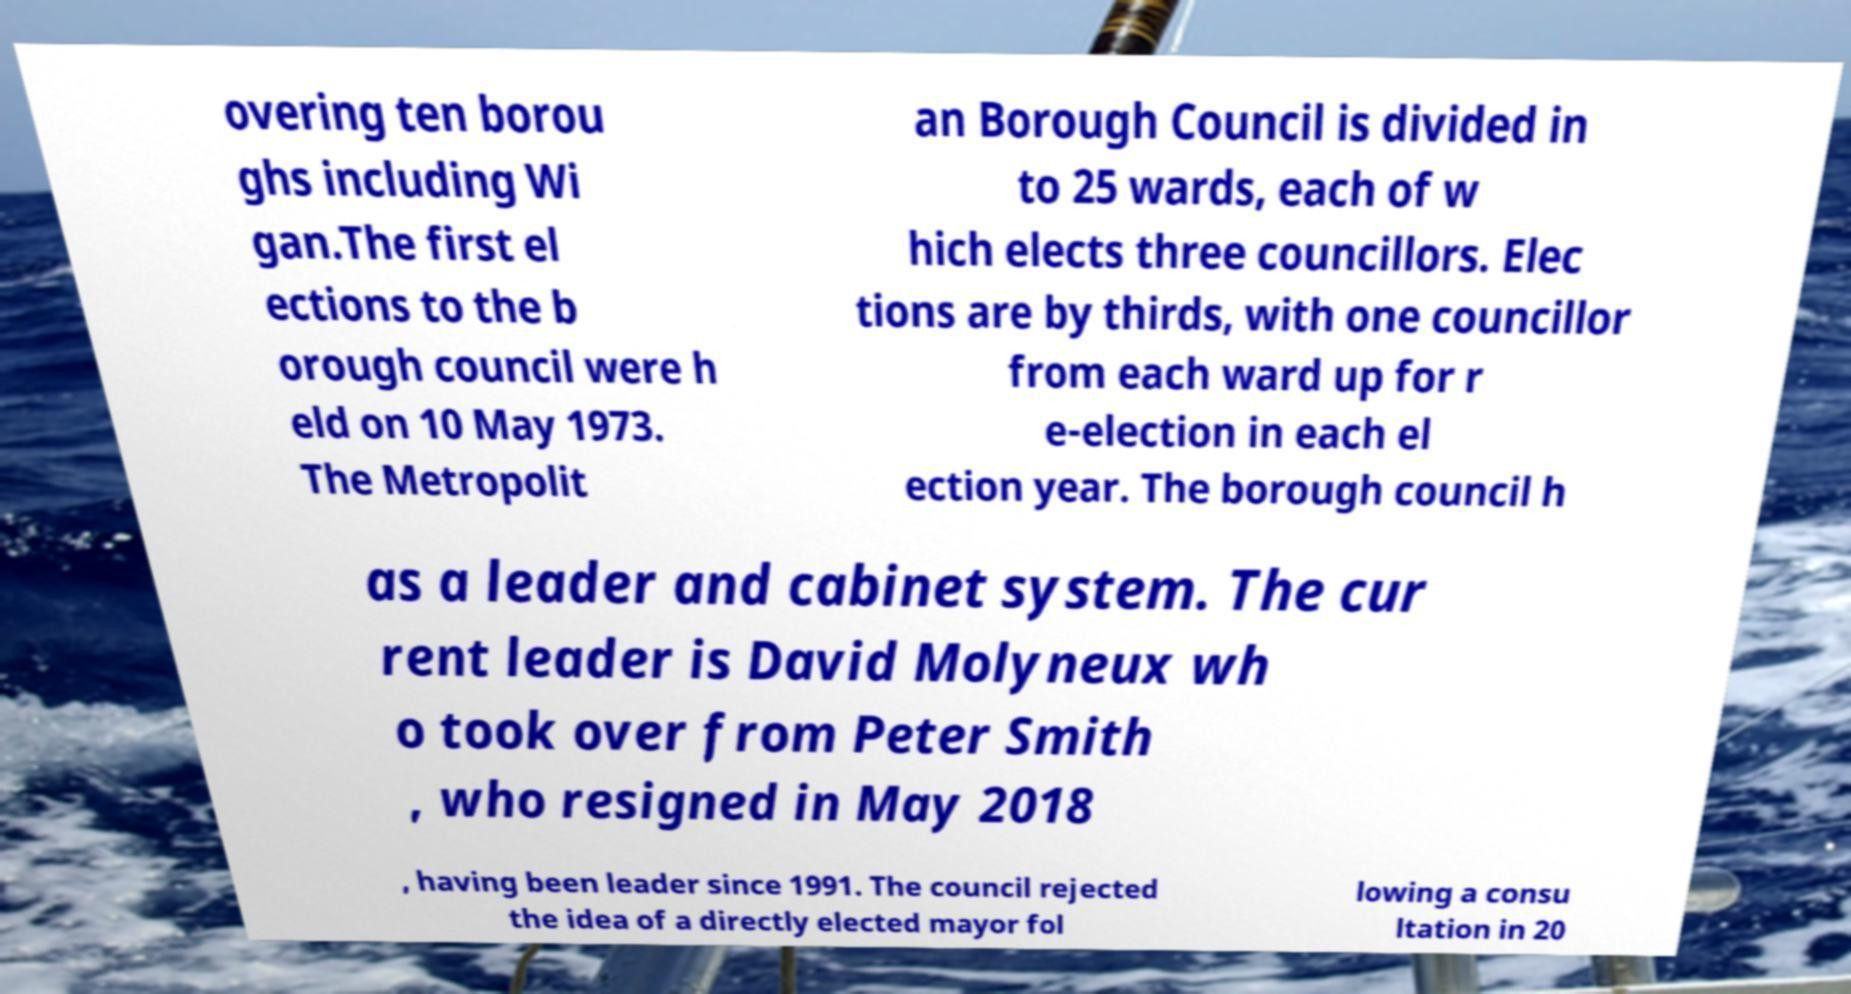Could you assist in decoding the text presented in this image and type it out clearly? overing ten borou ghs including Wi gan.The first el ections to the b orough council were h eld on 10 May 1973. The Metropolit an Borough Council is divided in to 25 wards, each of w hich elects three councillors. Elec tions are by thirds, with one councillor from each ward up for r e-election in each el ection year. The borough council h as a leader and cabinet system. The cur rent leader is David Molyneux wh o took over from Peter Smith , who resigned in May 2018 , having been leader since 1991. The council rejected the idea of a directly elected mayor fol lowing a consu ltation in 20 